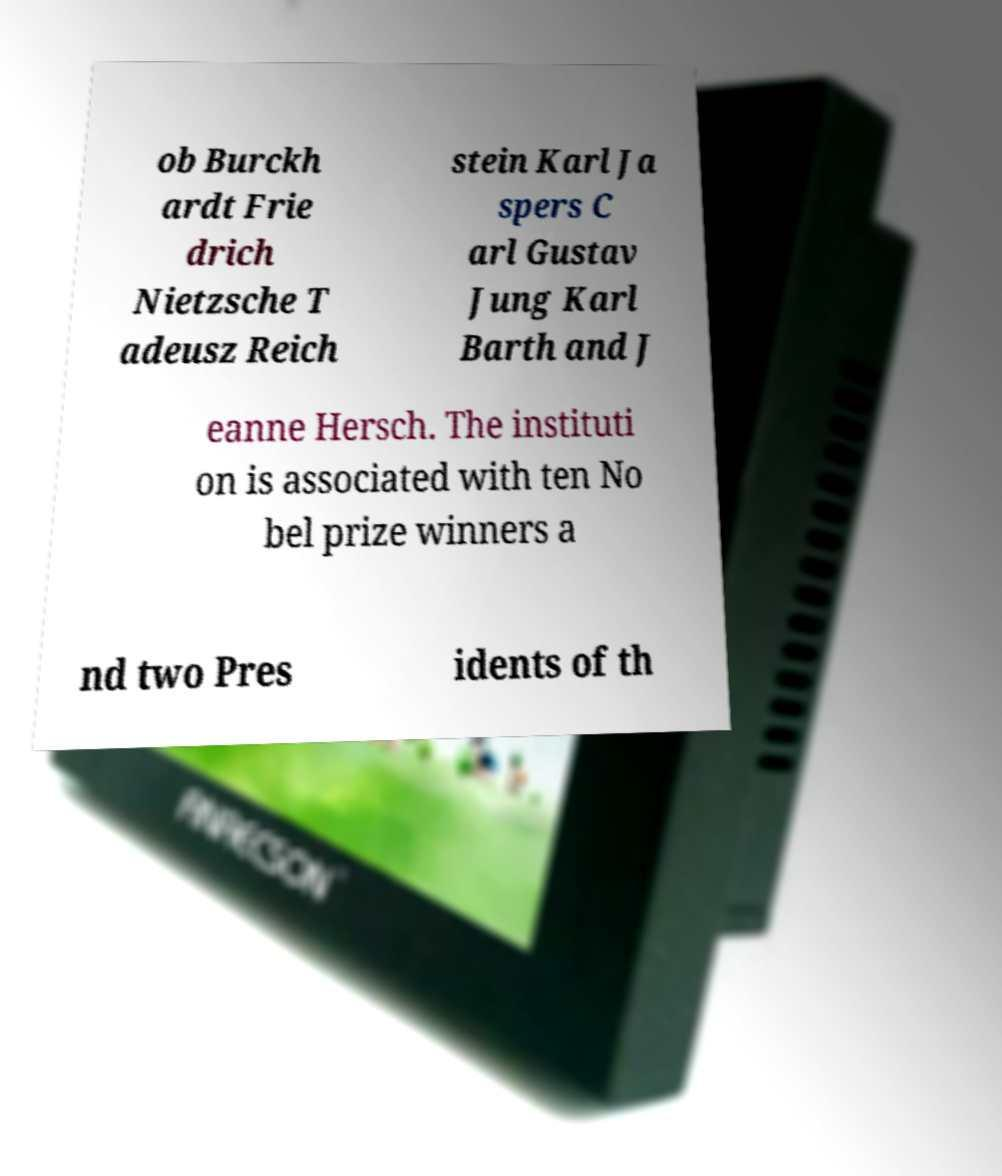There's text embedded in this image that I need extracted. Can you transcribe it verbatim? ob Burckh ardt Frie drich Nietzsche T adeusz Reich stein Karl Ja spers C arl Gustav Jung Karl Barth and J eanne Hersch. The instituti on is associated with ten No bel prize winners a nd two Pres idents of th 